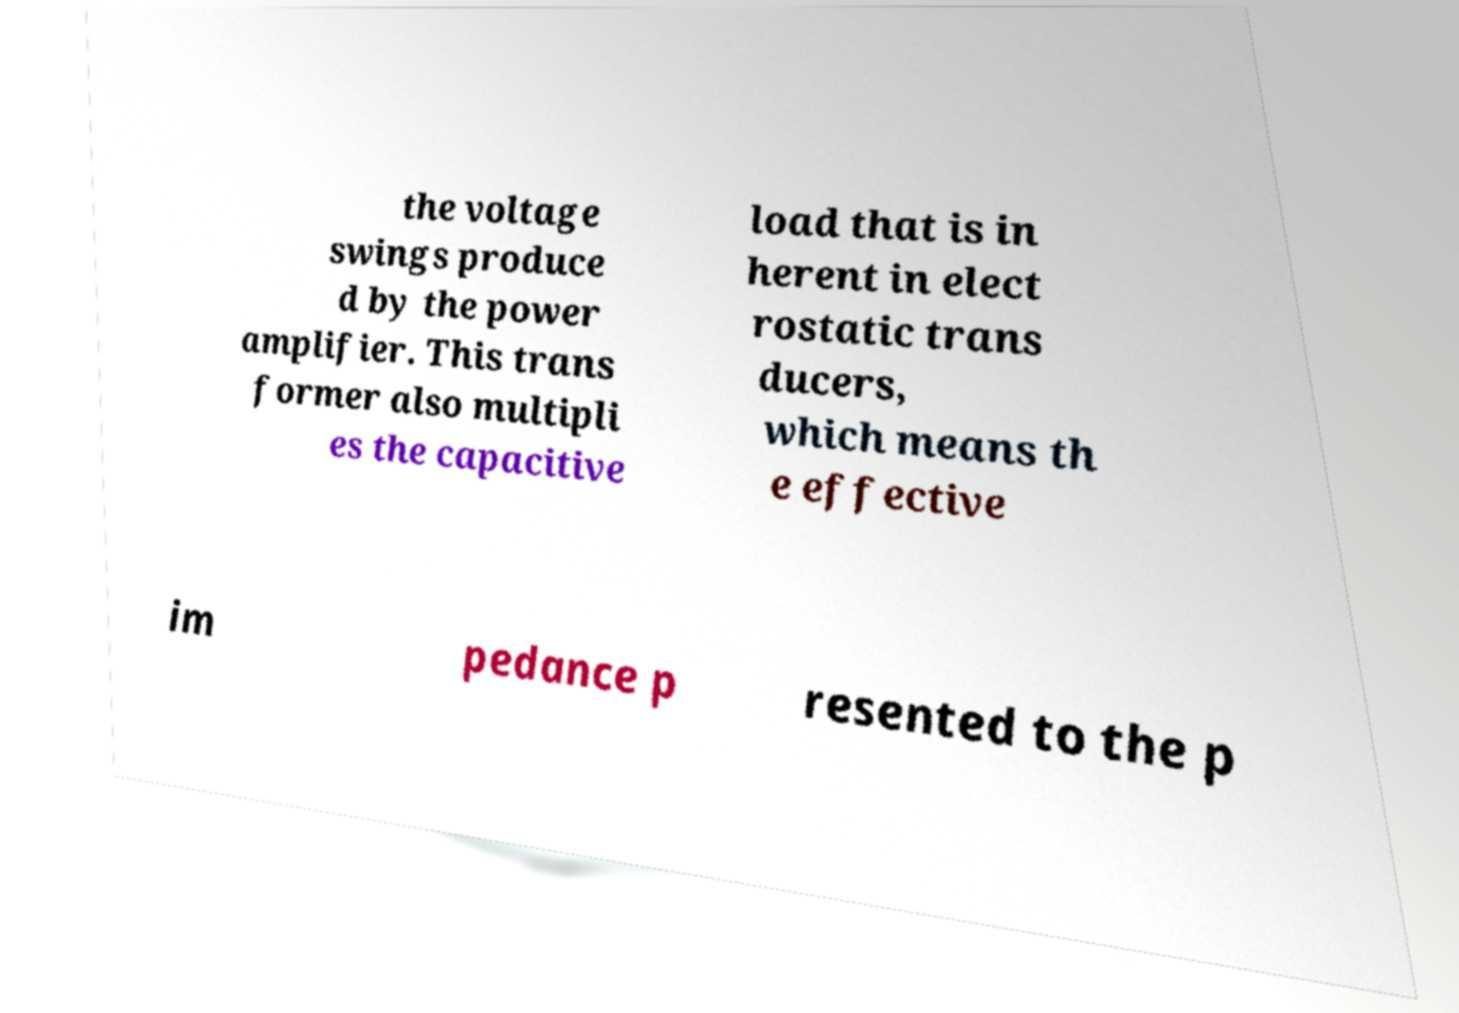For documentation purposes, I need the text within this image transcribed. Could you provide that? the voltage swings produce d by the power amplifier. This trans former also multipli es the capacitive load that is in herent in elect rostatic trans ducers, which means th e effective im pedance p resented to the p 